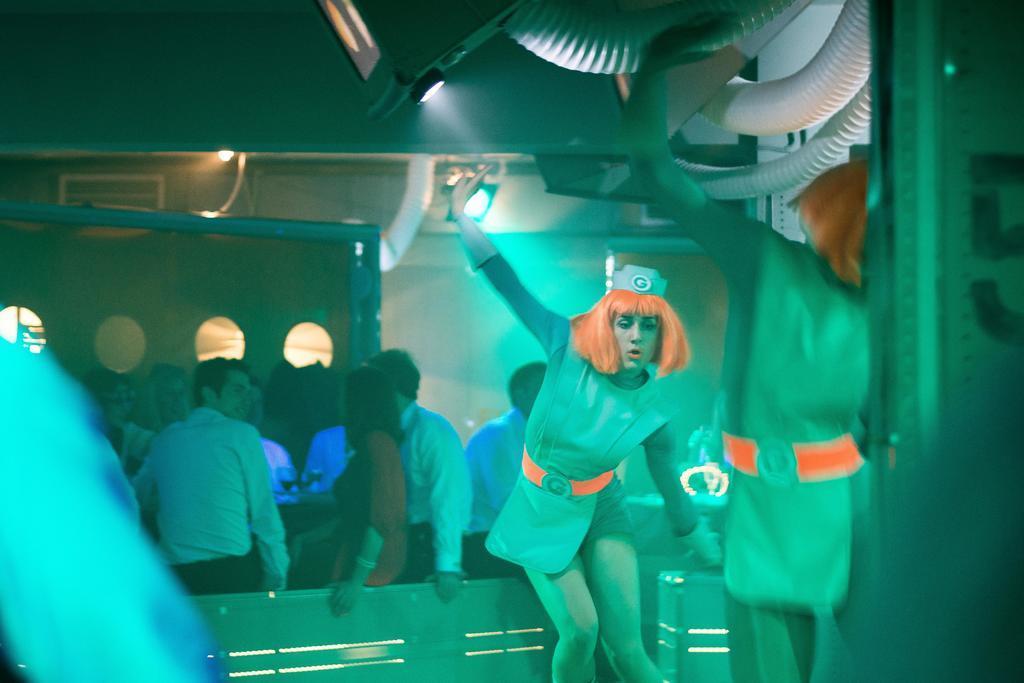How would you summarize this image in a sentence or two? This image consists of many persons. In the front, there are two women dancing. It looks like a pub. At the top, we can see pipes in white color. In the background, there is a wall. 